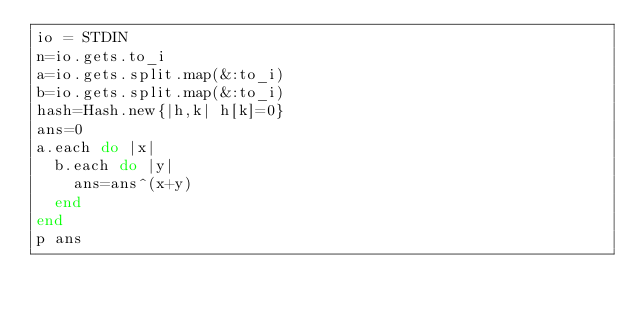<code> <loc_0><loc_0><loc_500><loc_500><_Ruby_>io = STDIN
n=io.gets.to_i
a=io.gets.split.map(&:to_i)
b=io.gets.split.map(&:to_i)
hash=Hash.new{|h,k| h[k]=0}
ans=0
a.each do |x|
  b.each do |y|
    ans=ans^(x+y)
  end
end
p ans
</code> 